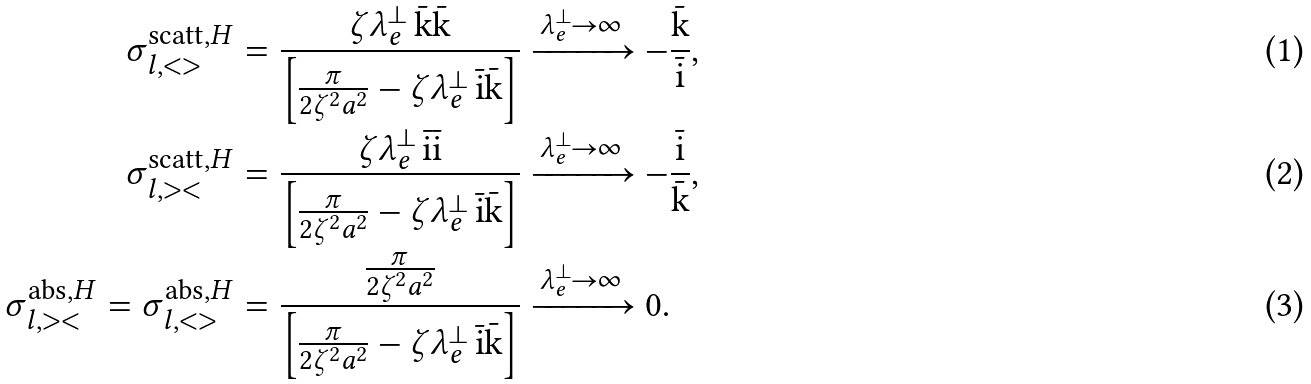<formula> <loc_0><loc_0><loc_500><loc_500>\sigma ^ { \text {scatt} , H } _ { l , < > } & = \frac { \zeta \lambda ^ { \perp } _ { e } \, \bar { \text {k} } \bar { \text {k} } } { \left [ \frac { \pi } { 2 \zeta ^ { 2 } a ^ { 2 } } - \zeta \lambda ^ { \perp } _ { e } \, \bar { \text {i} } \bar { \text {k} } \right ] } \xrightarrow { \lambda ^ { \perp } _ { e } \to \infty } - \frac { \bar { \text {k} } } { \bar { \text {i} } } , \\ \sigma ^ { \text {scatt} , H } _ { l , > < } & = \frac { \zeta \lambda ^ { \perp } _ { e } \, \bar { \text {i} } \bar { \text {i} } } { \left [ \frac { \pi } { 2 \zeta ^ { 2 } a ^ { 2 } } - \zeta \lambda ^ { \perp } _ { e } \, \bar { \text {i} } \bar { \text {k} } \right ] } \xrightarrow { \lambda ^ { \perp } _ { e } \to \infty } - \frac { \bar { \text {i} } } { \bar { \text {k} } } , \\ \sigma ^ { \text {abs} , H } _ { l , > < } = \sigma ^ { \text {abs} , H } _ { l , < > } & = \frac { \frac { \pi } { 2 \zeta ^ { 2 } a ^ { 2 } } } { \left [ \frac { \pi } { 2 \zeta ^ { 2 } a ^ { 2 } } - \zeta \lambda ^ { \perp } _ { e } \, \bar { \text {i} } \bar { \text {k} } \right ] } \xrightarrow { \lambda ^ { \perp } _ { e } \to \infty } 0 .</formula> 